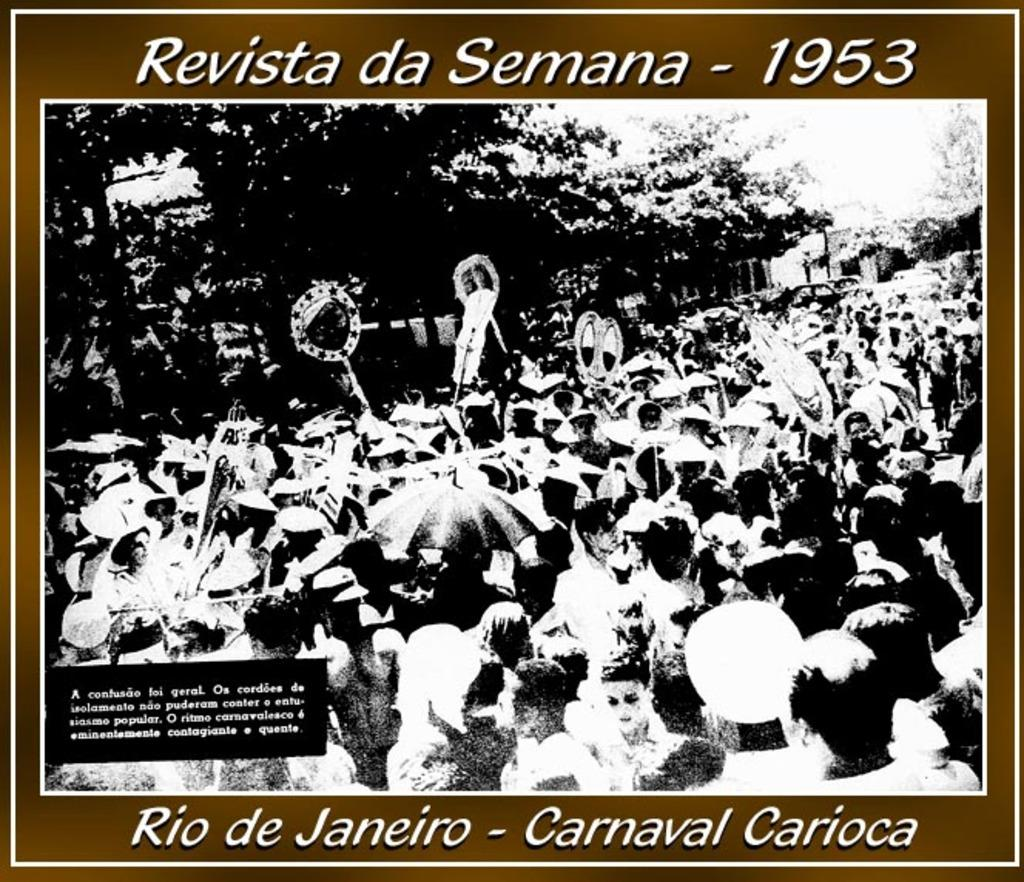What is the main subject of the image? The main subject of the image is a photo. What can be seen in the photo? The photo contains people, trees, and vehicles. Is there any text present on the photo? Yes, there is text written on the photo. What type of cable can be seen connecting the sun and the vehicles in the image? There is no cable connecting the sun and the vehicles in the image, as the sun is not present in the photo. 